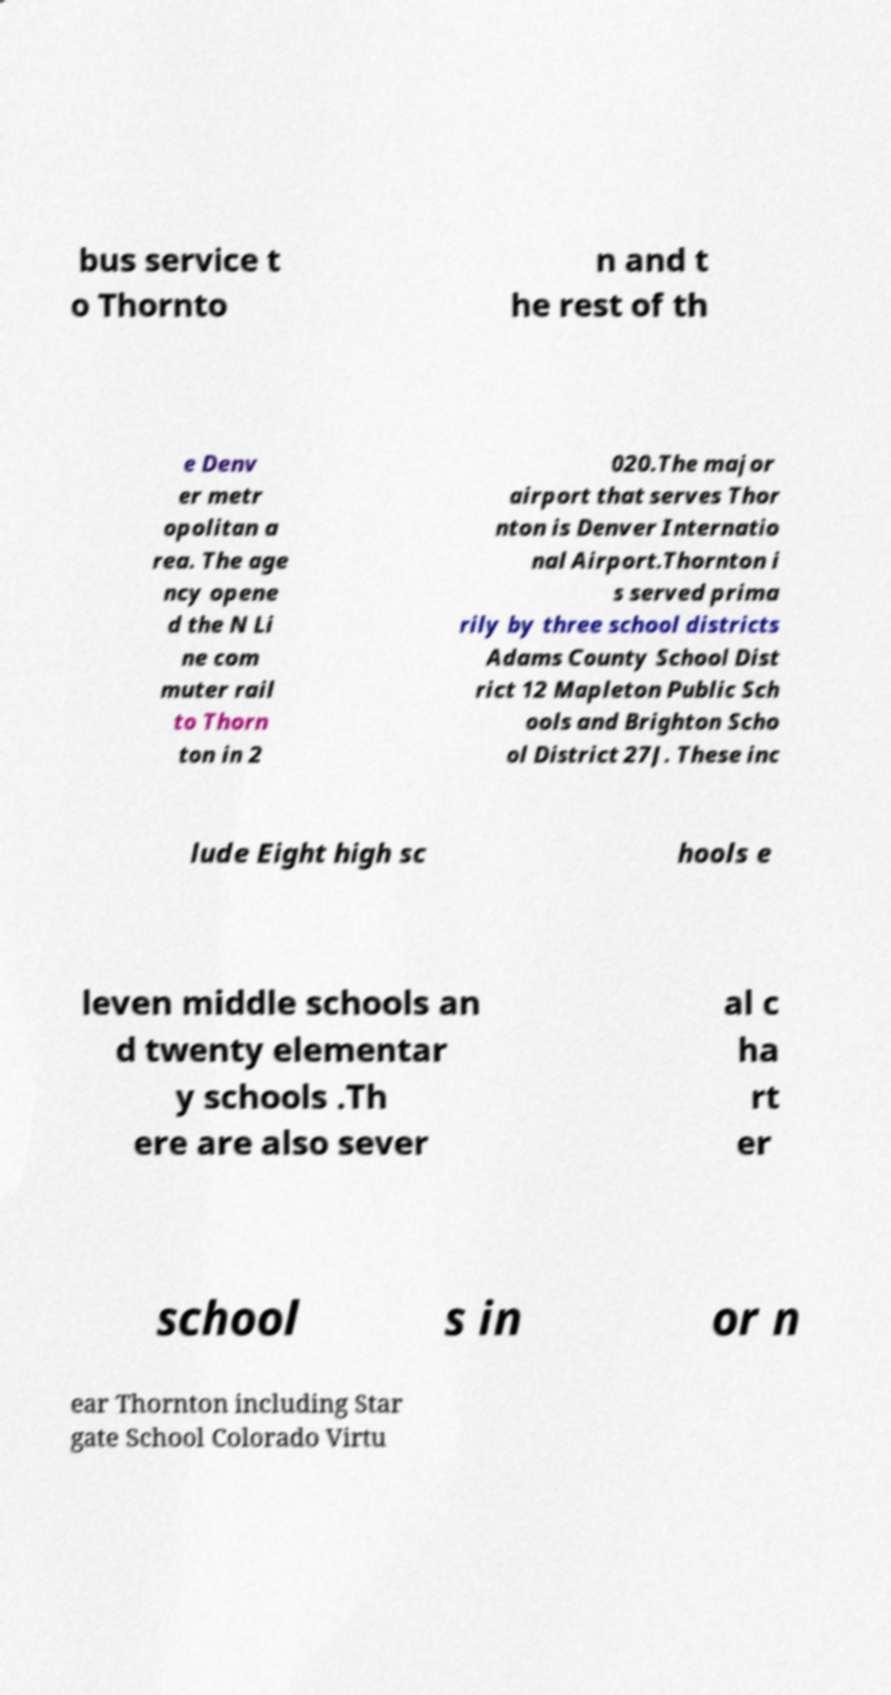What messages or text are displayed in this image? I need them in a readable, typed format. bus service t o Thornto n and t he rest of th e Denv er metr opolitan a rea. The age ncy opene d the N Li ne com muter rail to Thorn ton in 2 020.The major airport that serves Thor nton is Denver Internatio nal Airport.Thornton i s served prima rily by three school districts Adams County School Dist rict 12 Mapleton Public Sch ools and Brighton Scho ol District 27J. These inc lude Eight high sc hools e leven middle schools an d twenty elementar y schools .Th ere are also sever al c ha rt er school s in or n ear Thornton including Star gate School Colorado Virtu 